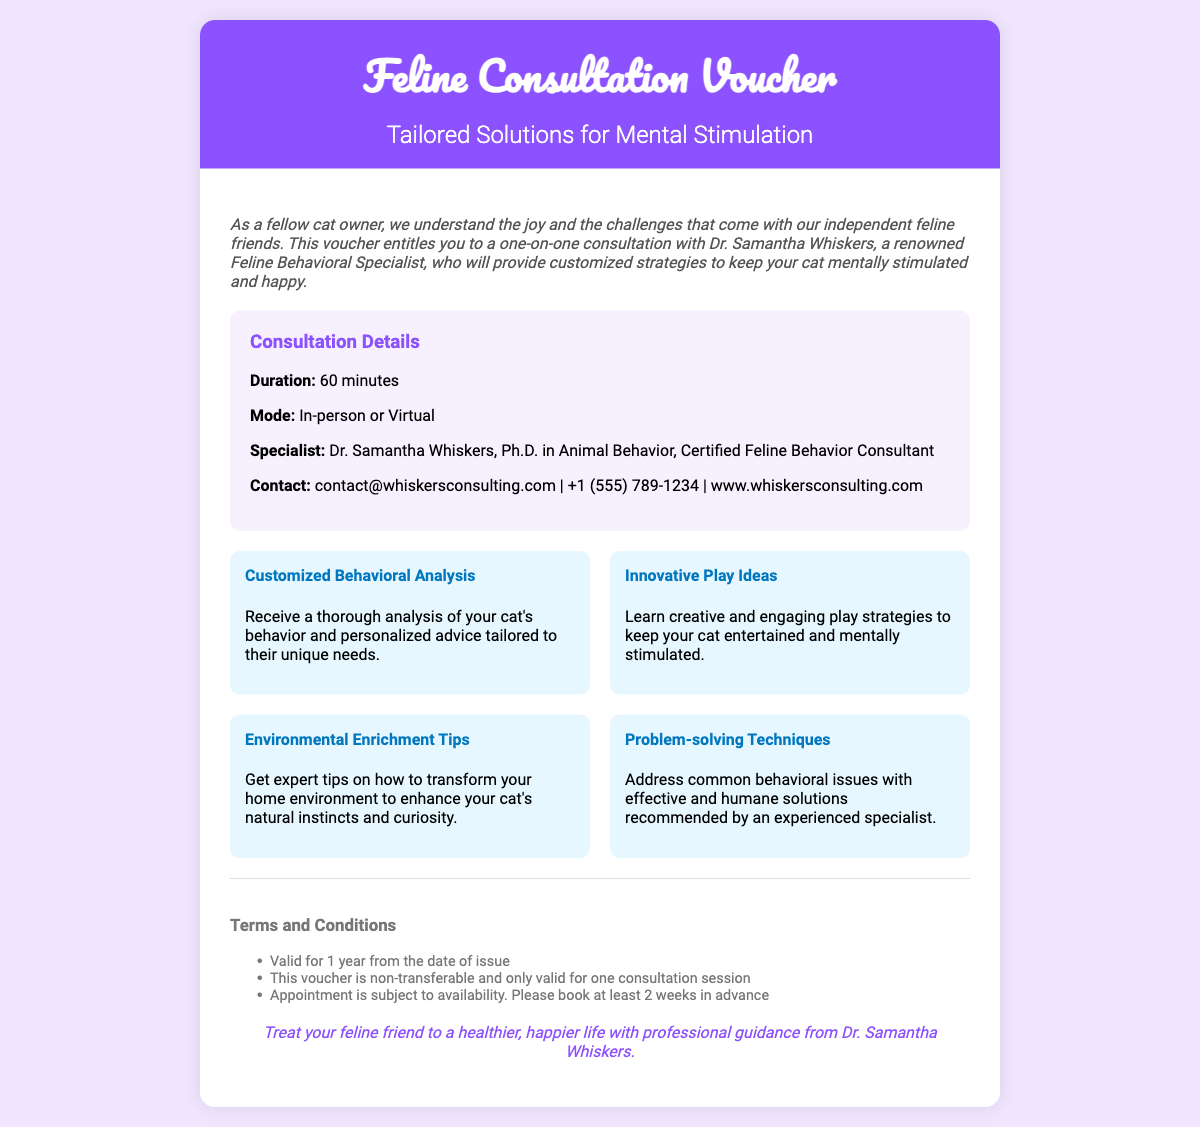What is the title of the consultation voucher? The title of the consultation voucher is stated prominently at the top of the document.
Answer: Feline Consultation Voucher Who is the feline behavioral specialist? The document provides the name of the specialist who will conduct the consultation.
Answer: Dr. Samantha Whiskers How long is the consultation? The duration of the consultation is mentioned in the details section of the document.
Answer: 60 minutes What is the mode of the consultation? The mode of consultation is specified in the consultation details section.
Answer: In-person or Virtual What type of analysis will be provided? The document mentions a specific type of analysis that will be offered during the consultation.
Answer: Customized Behavioral Analysis Which benefit focuses on play strategies? One of the sections highlights various benefits related to keeping cats entertained.
Answer: Innovative Play Ideas What is one of the terms and conditions regarding transferability? One of the terms states specific rules about the voucher's use.
Answer: This voucher is non-transferable How far in advance should the appointment be booked? The document specifies how much notice is needed for scheduling an appointment.
Answer: At least 2 weeks in advance How long is the voucher valid? The validity period of the voucher is indicated clearly in the terms section.
Answer: 1 year from the date of issue 